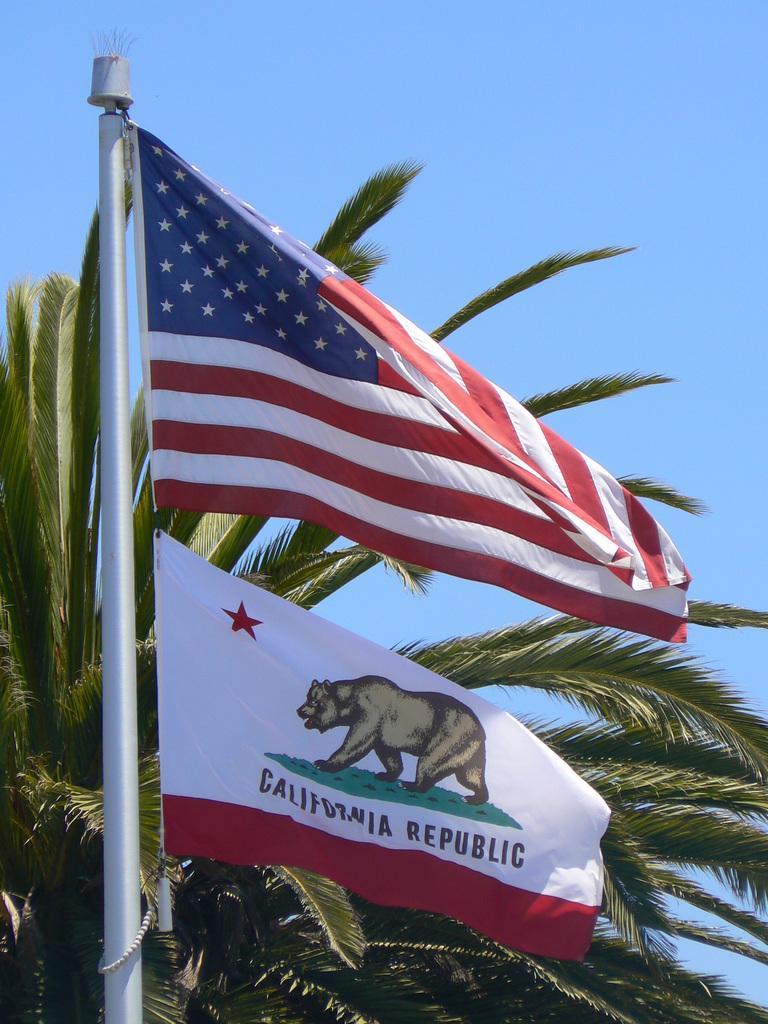Please provide a concise description of this image. In this image I can see two flags attached to the pole. In the background I can see few trees in green color and the sky is in blue color. 